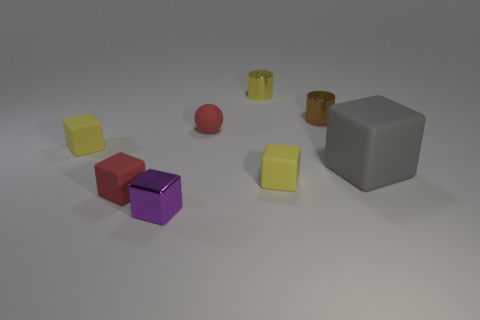Imagine if these objects were part of a game, what could be the rules? If these objects were part of a game, we could imagine several rules. For example, the cubes could represent building blocks that players must stack without toppling, whereas the cylinders could serve as 'roll' challenges where players must roll them to a specific target area. The sphere could be a bonus item, perhaps granting extra points if caught after a single bounce. The grey cube might serve as a 'wildcard' obstacle, changing positions between rounds of the game to increase difficulty. 